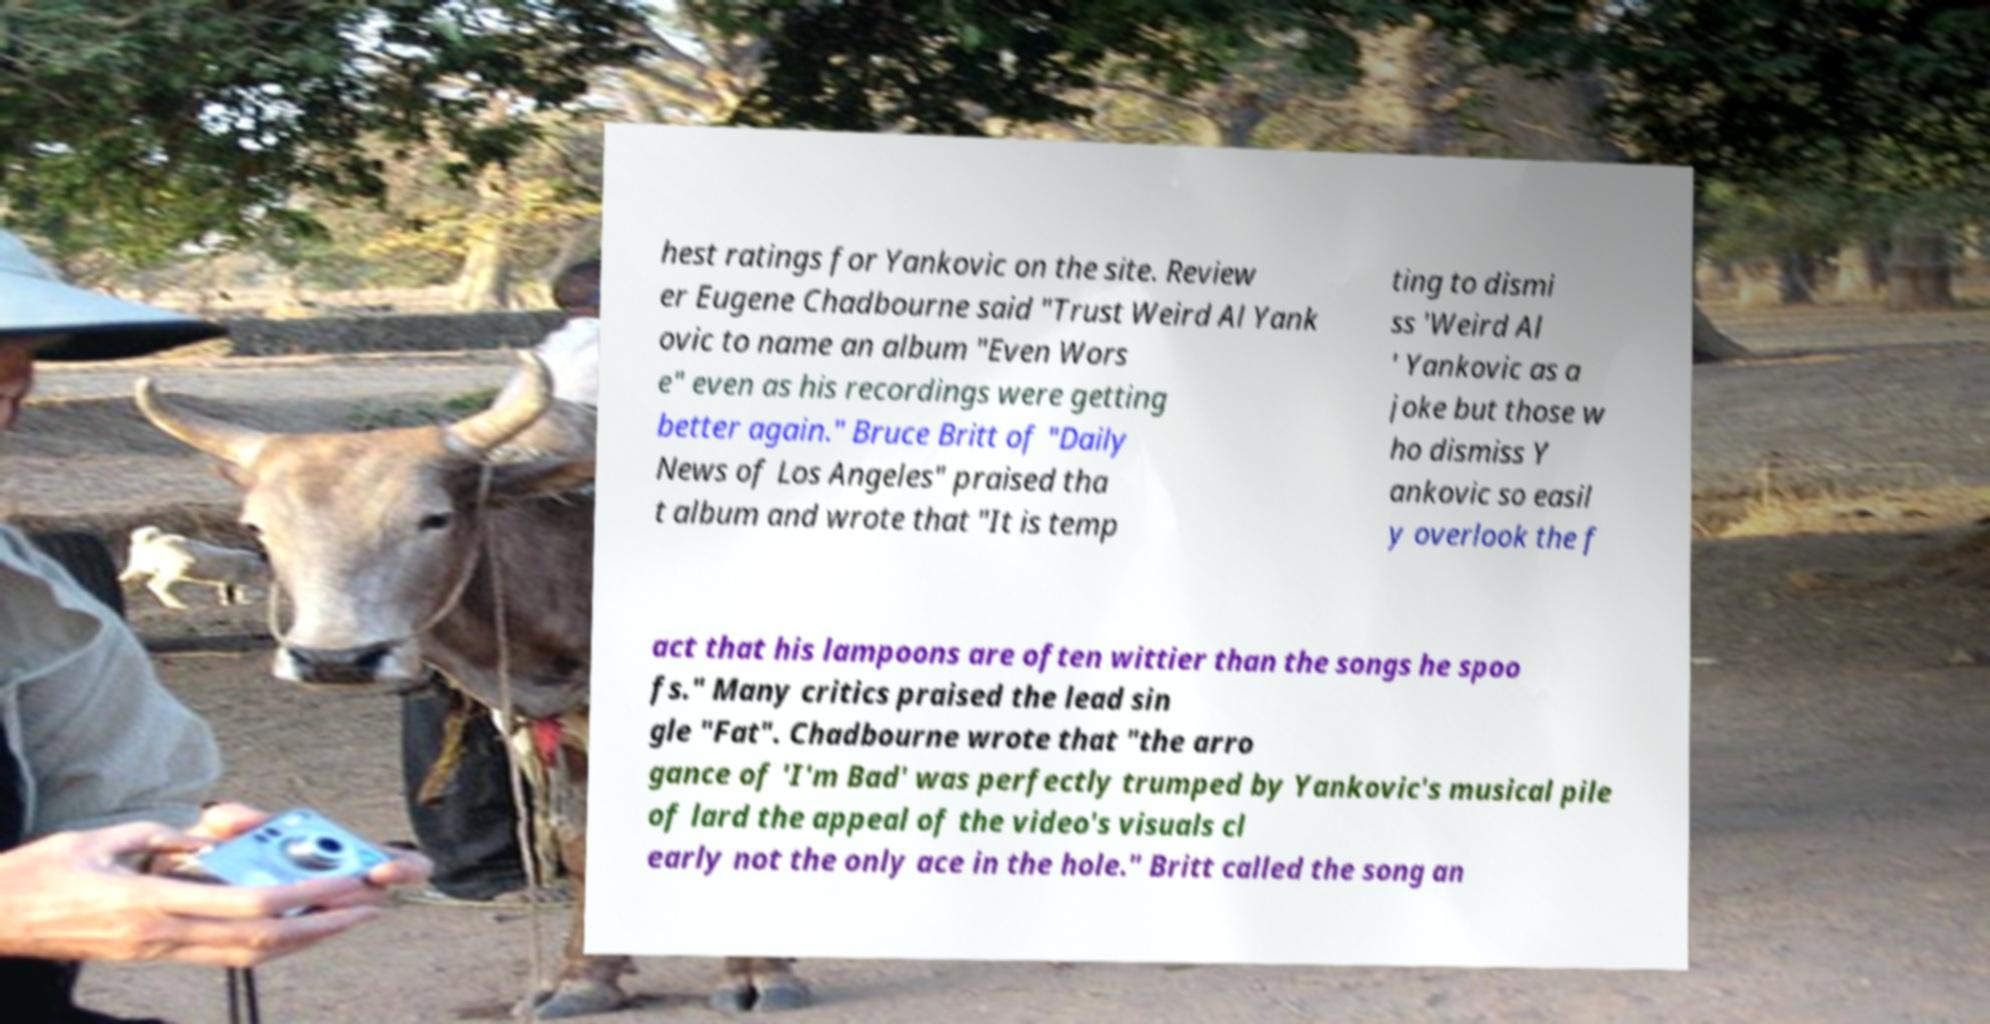I need the written content from this picture converted into text. Can you do that? hest ratings for Yankovic on the site. Review er Eugene Chadbourne said "Trust Weird Al Yank ovic to name an album "Even Wors e" even as his recordings were getting better again." Bruce Britt of "Daily News of Los Angeles" praised tha t album and wrote that "It is temp ting to dismi ss 'Weird Al ' Yankovic as a joke but those w ho dismiss Y ankovic so easil y overlook the f act that his lampoons are often wittier than the songs he spoo fs." Many critics praised the lead sin gle "Fat". Chadbourne wrote that "the arro gance of 'I'm Bad' was perfectly trumped by Yankovic's musical pile of lard the appeal of the video's visuals cl early not the only ace in the hole." Britt called the song an 